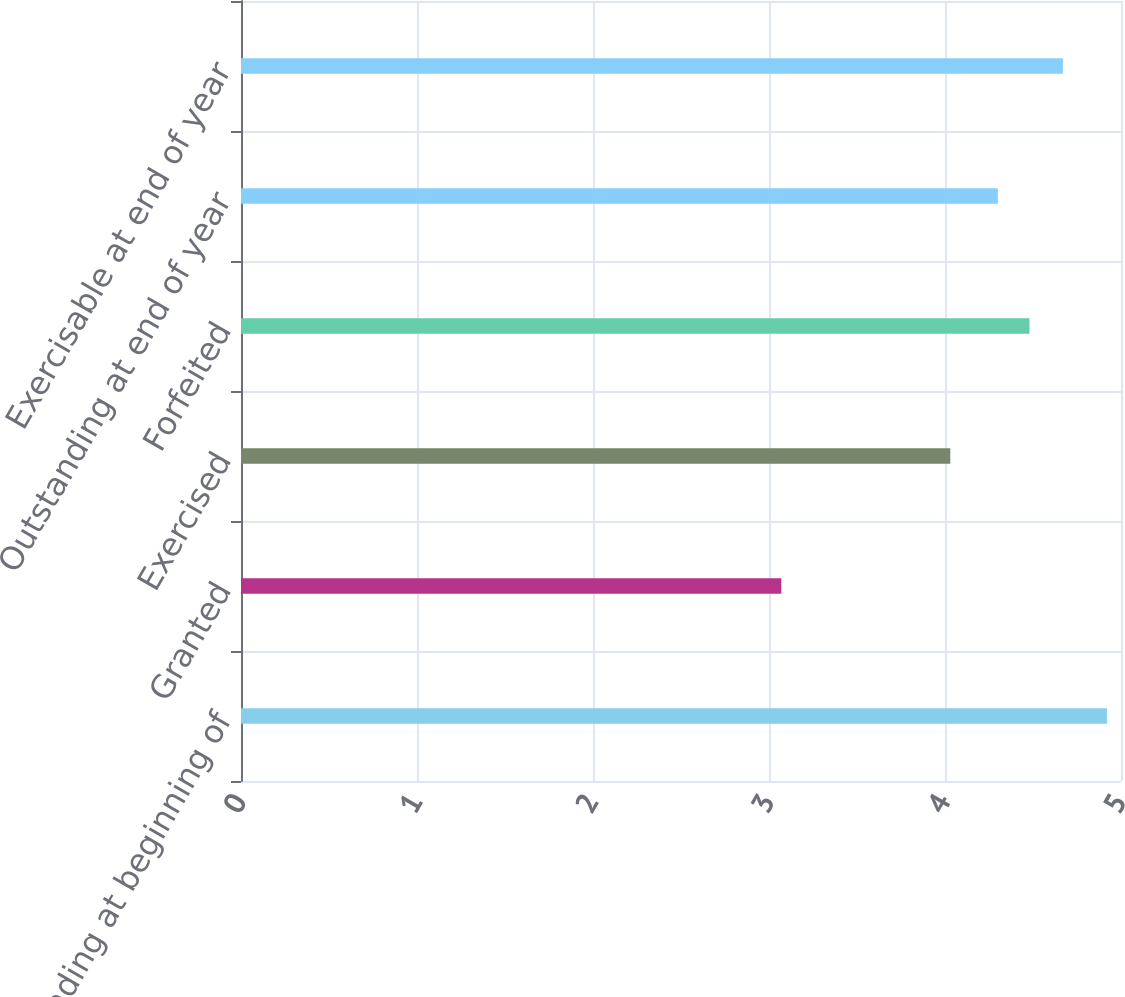<chart> <loc_0><loc_0><loc_500><loc_500><bar_chart><fcel>Outstanding at beginning of<fcel>Granted<fcel>Exercised<fcel>Forfeited<fcel>Outstanding at end of year<fcel>Exercisable at end of year<nl><fcel>4.92<fcel>3.07<fcel>4.03<fcel>4.48<fcel>4.3<fcel>4.67<nl></chart> 